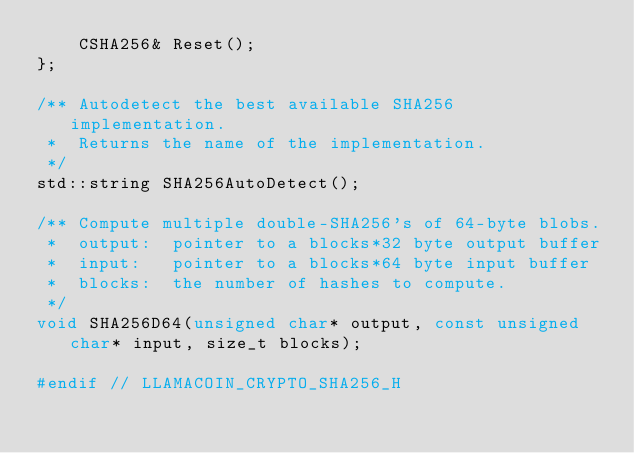Convert code to text. <code><loc_0><loc_0><loc_500><loc_500><_C_>    CSHA256& Reset();
};

/** Autodetect the best available SHA256 implementation.
 *  Returns the name of the implementation.
 */
std::string SHA256AutoDetect();

/** Compute multiple double-SHA256's of 64-byte blobs.
 *  output:  pointer to a blocks*32 byte output buffer
 *  input:   pointer to a blocks*64 byte input buffer
 *  blocks:  the number of hashes to compute.
 */
void SHA256D64(unsigned char* output, const unsigned char* input, size_t blocks);

#endif // LLAMACOIN_CRYPTO_SHA256_H
</code> 